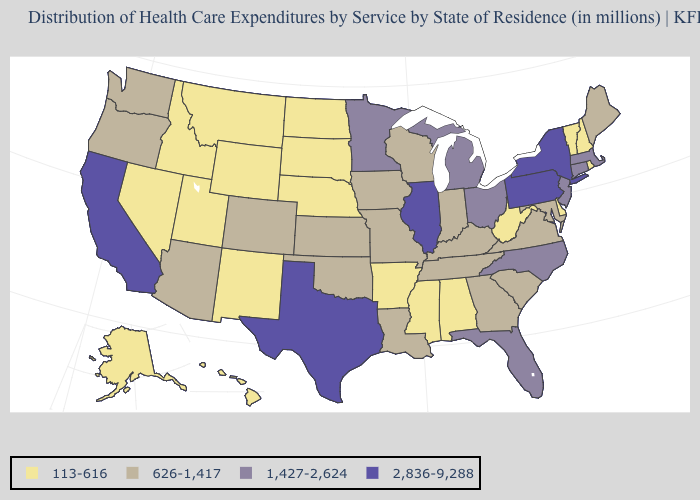Name the states that have a value in the range 113-616?
Concise answer only. Alabama, Alaska, Arkansas, Delaware, Hawaii, Idaho, Mississippi, Montana, Nebraska, Nevada, New Hampshire, New Mexico, North Dakota, Rhode Island, South Dakota, Utah, Vermont, West Virginia, Wyoming. What is the value of North Dakota?
Be succinct. 113-616. How many symbols are there in the legend?
Write a very short answer. 4. What is the value of Ohio?
Write a very short answer. 1,427-2,624. Name the states that have a value in the range 113-616?
Concise answer only. Alabama, Alaska, Arkansas, Delaware, Hawaii, Idaho, Mississippi, Montana, Nebraska, Nevada, New Hampshire, New Mexico, North Dakota, Rhode Island, South Dakota, Utah, Vermont, West Virginia, Wyoming. Does the first symbol in the legend represent the smallest category?
Keep it brief. Yes. Among the states that border Utah , does Colorado have the highest value?
Quick response, please. Yes. Among the states that border Iowa , which have the highest value?
Give a very brief answer. Illinois. What is the value of Maryland?
Be succinct. 626-1,417. Which states have the lowest value in the MidWest?
Be succinct. Nebraska, North Dakota, South Dakota. Name the states that have a value in the range 2,836-9,288?
Concise answer only. California, Illinois, New York, Pennsylvania, Texas. Which states have the lowest value in the USA?
Write a very short answer. Alabama, Alaska, Arkansas, Delaware, Hawaii, Idaho, Mississippi, Montana, Nebraska, Nevada, New Hampshire, New Mexico, North Dakota, Rhode Island, South Dakota, Utah, Vermont, West Virginia, Wyoming. Is the legend a continuous bar?
Keep it brief. No. Does Vermont have the highest value in the Northeast?
Concise answer only. No. Does Nebraska have a lower value than New Jersey?
Answer briefly. Yes. 